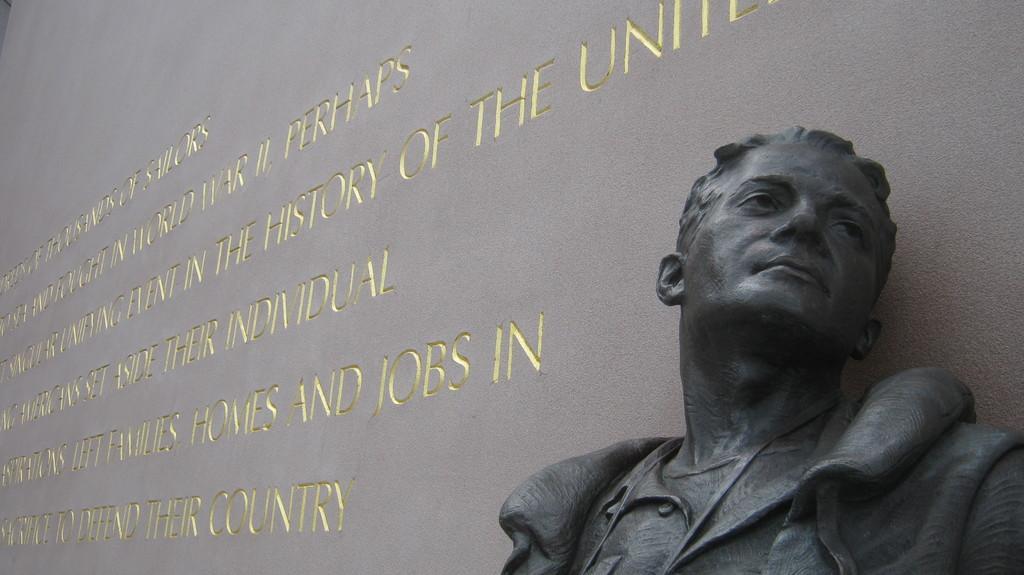How would you summarize this image in a sentence or two? In this image we can see the sculpture near the wall and we can see the text written on the wall. 